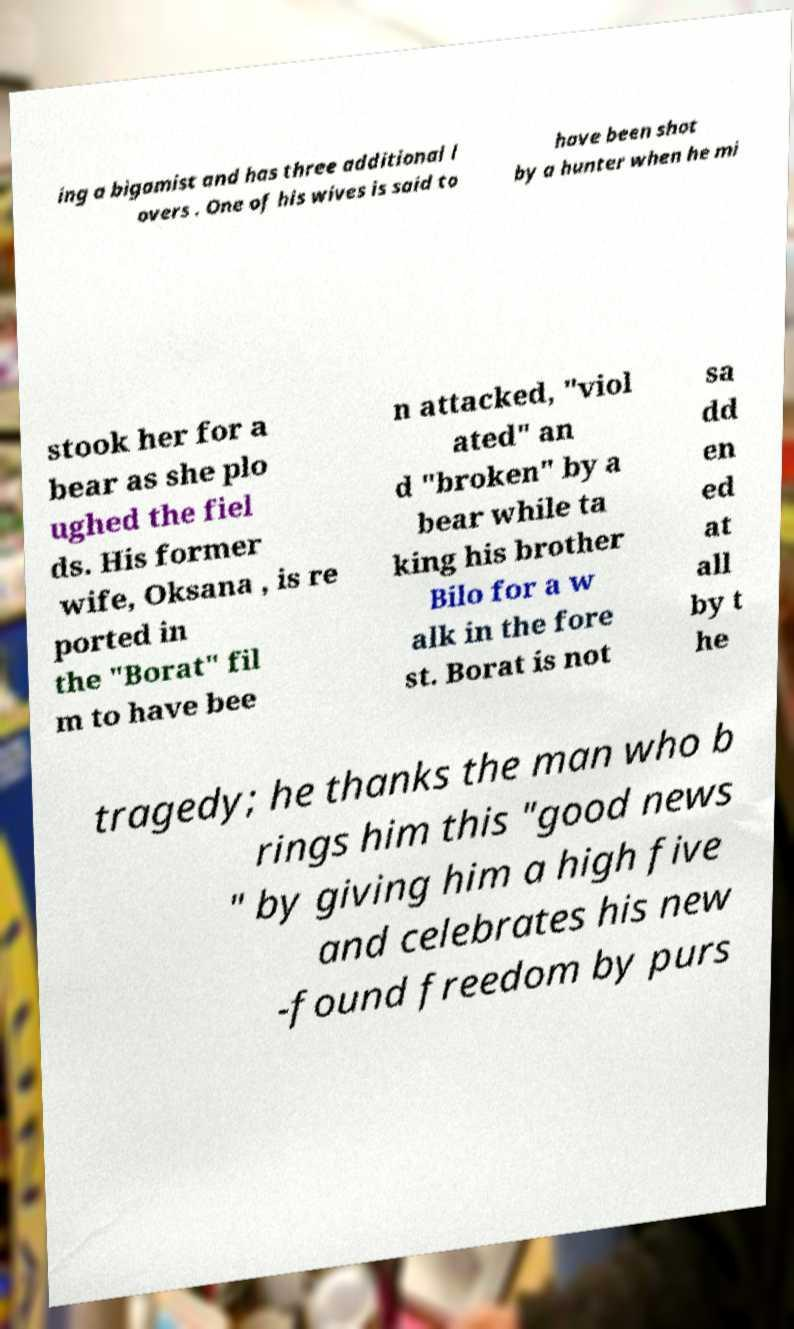There's text embedded in this image that I need extracted. Can you transcribe it verbatim? ing a bigamist and has three additional l overs . One of his wives is said to have been shot by a hunter when he mi stook her for a bear as she plo ughed the fiel ds. His former wife, Oksana , is re ported in the "Borat" fil m to have bee n attacked, "viol ated" an d "broken" by a bear while ta king his brother Bilo for a w alk in the fore st. Borat is not sa dd en ed at all by t he tragedy; he thanks the man who b rings him this "good news " by giving him a high five and celebrates his new -found freedom by purs 